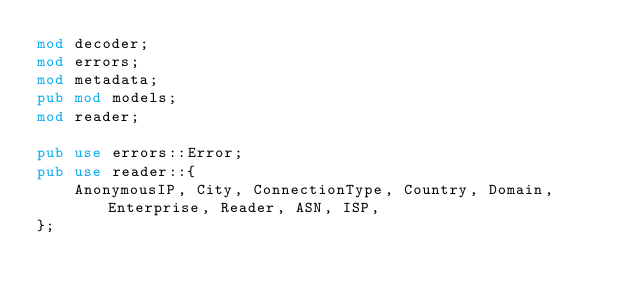<code> <loc_0><loc_0><loc_500><loc_500><_Rust_>mod decoder;
mod errors;
mod metadata;
pub mod models;
mod reader;

pub use errors::Error;
pub use reader::{
    AnonymousIP, City, ConnectionType, Country, Domain, Enterprise, Reader, ASN, ISP,
};
</code> 